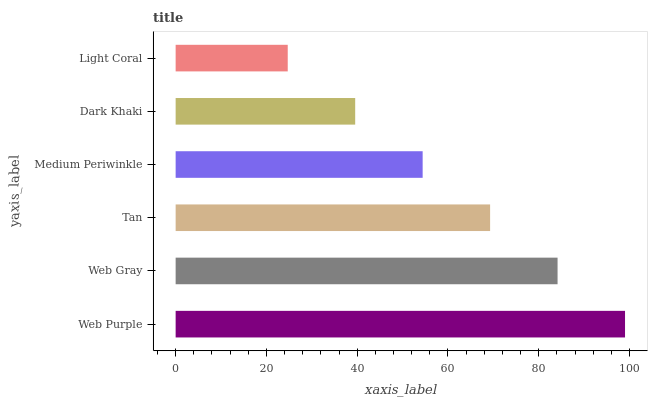Is Light Coral the minimum?
Answer yes or no. Yes. Is Web Purple the maximum?
Answer yes or no. Yes. Is Web Gray the minimum?
Answer yes or no. No. Is Web Gray the maximum?
Answer yes or no. No. Is Web Purple greater than Web Gray?
Answer yes or no. Yes. Is Web Gray less than Web Purple?
Answer yes or no. Yes. Is Web Gray greater than Web Purple?
Answer yes or no. No. Is Web Purple less than Web Gray?
Answer yes or no. No. Is Tan the high median?
Answer yes or no. Yes. Is Medium Periwinkle the low median?
Answer yes or no. Yes. Is Web Gray the high median?
Answer yes or no. No. Is Light Coral the low median?
Answer yes or no. No. 